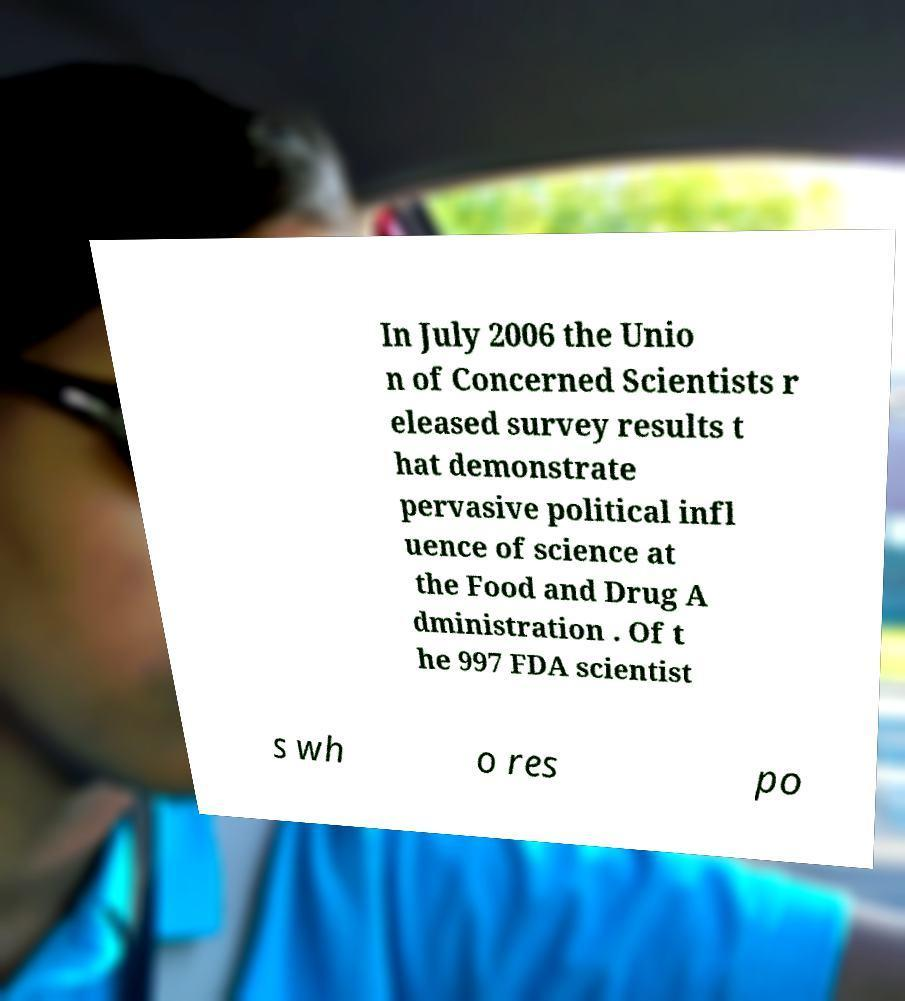There's text embedded in this image that I need extracted. Can you transcribe it verbatim? In July 2006 the Unio n of Concerned Scientists r eleased survey results t hat demonstrate pervasive political infl uence of science at the Food and Drug A dministration . Of t he 997 FDA scientist s wh o res po 